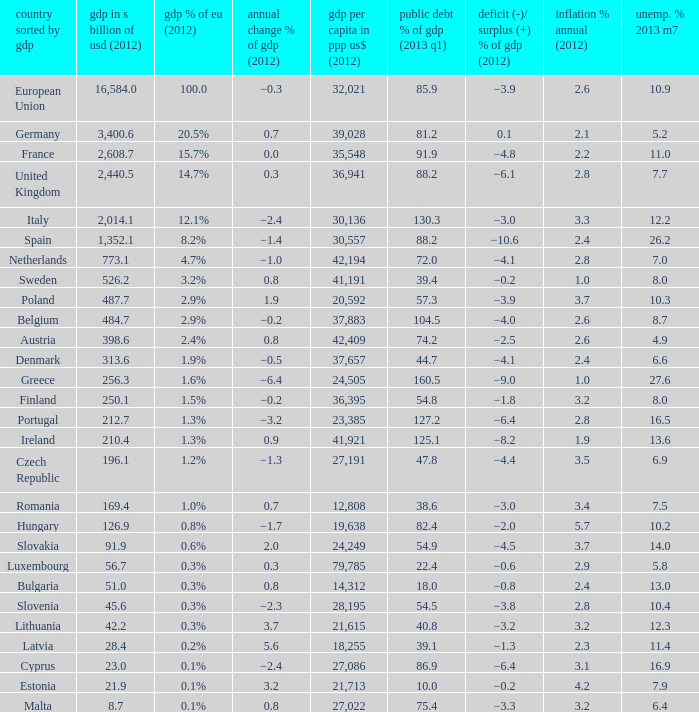What is the average public debt % of GDP in 2013 Q1 of the country with a member slate sorted by GDP of Czech Republic and a GDP per capita in PPP US dollars in 2012 greater than 27,191? None. 